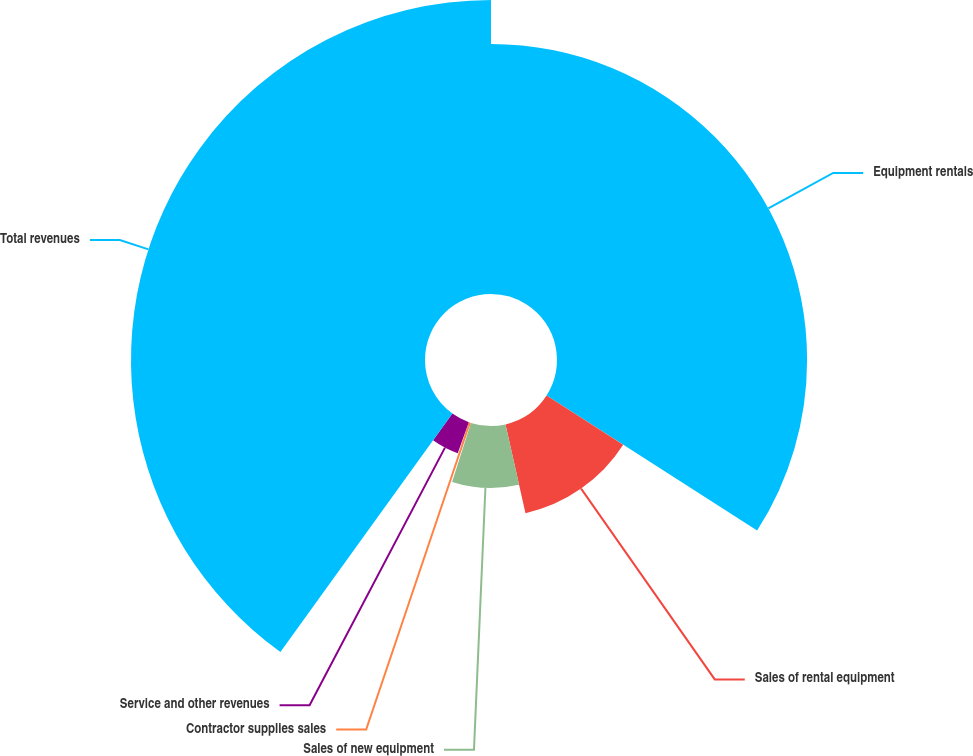Convert chart to OTSL. <chart><loc_0><loc_0><loc_500><loc_500><pie_chart><fcel>Equipment rentals<fcel>Sales of rental equipment<fcel>Sales of new equipment<fcel>Contractor supplies sales<fcel>Service and other revenues<fcel>Total revenues<nl><fcel>34.07%<fcel>12.4%<fcel>8.44%<fcel>0.54%<fcel>4.49%<fcel>40.05%<nl></chart> 